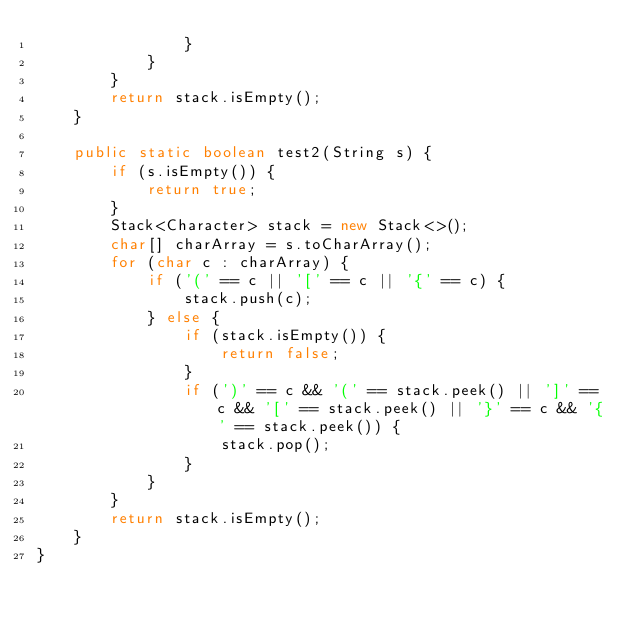<code> <loc_0><loc_0><loc_500><loc_500><_Java_>                }
            }
        }
        return stack.isEmpty();
    }

    public static boolean test2(String s) {
        if (s.isEmpty()) {
            return true;
        }
        Stack<Character> stack = new Stack<>();
        char[] charArray = s.toCharArray();
        for (char c : charArray) {
            if ('(' == c || '[' == c || '{' == c) {
                stack.push(c);
            } else {
                if (stack.isEmpty()) {
                    return false;
                }
                if (')' == c && '(' == stack.peek() || ']' == c && '[' == stack.peek() || '}' == c && '{' == stack.peek()) {
                    stack.pop();
                }
            }
        }
        return stack.isEmpty();
    }
}
</code> 